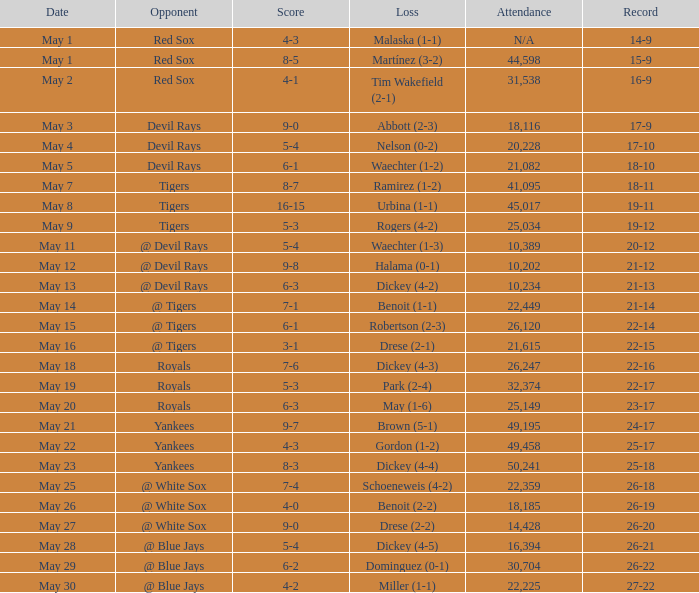What was the outcome of the match featuring a defeat of drese (2-2)? 9-0. Can you parse all the data within this table? {'header': ['Date', 'Opponent', 'Score', 'Loss', 'Attendance', 'Record'], 'rows': [['May 1', 'Red Sox', '4-3', 'Malaska (1-1)', 'N/A', '14-9'], ['May 1', 'Red Sox', '8-5', 'Martínez (3-2)', '44,598', '15-9'], ['May 2', 'Red Sox', '4-1', 'Tim Wakefield (2-1)', '31,538', '16-9'], ['May 3', 'Devil Rays', '9-0', 'Abbott (2-3)', '18,116', '17-9'], ['May 4', 'Devil Rays', '5-4', 'Nelson (0-2)', '20,228', '17-10'], ['May 5', 'Devil Rays', '6-1', 'Waechter (1-2)', '21,082', '18-10'], ['May 7', 'Tigers', '8-7', 'Ramirez (1-2)', '41,095', '18-11'], ['May 8', 'Tigers', '16-15', 'Urbina (1-1)', '45,017', '19-11'], ['May 9', 'Tigers', '5-3', 'Rogers (4-2)', '25,034', '19-12'], ['May 11', '@ Devil Rays', '5-4', 'Waechter (1-3)', '10,389', '20-12'], ['May 12', '@ Devil Rays', '9-8', 'Halama (0-1)', '10,202', '21-12'], ['May 13', '@ Devil Rays', '6-3', 'Dickey (4-2)', '10,234', '21-13'], ['May 14', '@ Tigers', '7-1', 'Benoit (1-1)', '22,449', '21-14'], ['May 15', '@ Tigers', '6-1', 'Robertson (2-3)', '26,120', '22-14'], ['May 16', '@ Tigers', '3-1', 'Drese (2-1)', '21,615', '22-15'], ['May 18', 'Royals', '7-6', 'Dickey (4-3)', '26,247', '22-16'], ['May 19', 'Royals', '5-3', 'Park (2-4)', '32,374', '22-17'], ['May 20', 'Royals', '6-3', 'May (1-6)', '25,149', '23-17'], ['May 21', 'Yankees', '9-7', 'Brown (5-1)', '49,195', '24-17'], ['May 22', 'Yankees', '4-3', 'Gordon (1-2)', '49,458', '25-17'], ['May 23', 'Yankees', '8-3', 'Dickey (4-4)', '50,241', '25-18'], ['May 25', '@ White Sox', '7-4', 'Schoeneweis (4-2)', '22,359', '26-18'], ['May 26', '@ White Sox', '4-0', 'Benoit (2-2)', '18,185', '26-19'], ['May 27', '@ White Sox', '9-0', 'Drese (2-2)', '14,428', '26-20'], ['May 28', '@ Blue Jays', '5-4', 'Dickey (4-5)', '16,394', '26-21'], ['May 29', '@ Blue Jays', '6-2', 'Dominguez (0-1)', '30,704', '26-22'], ['May 30', '@ Blue Jays', '4-2', 'Miller (1-1)', '22,225', '27-22']]} 